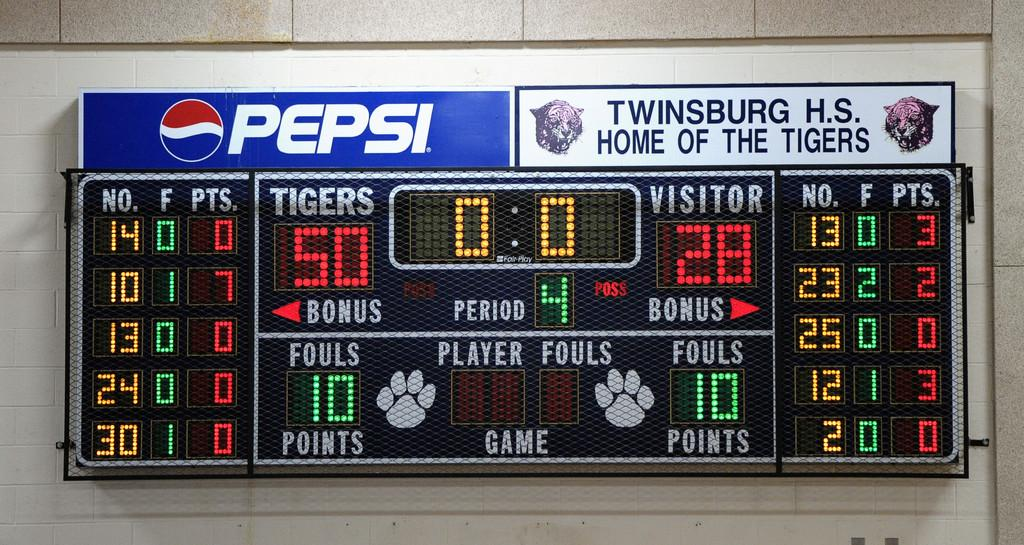<image>
Provide a brief description of the given image. A Twinsburg H.S. scoreboard shows the home team is winning. 